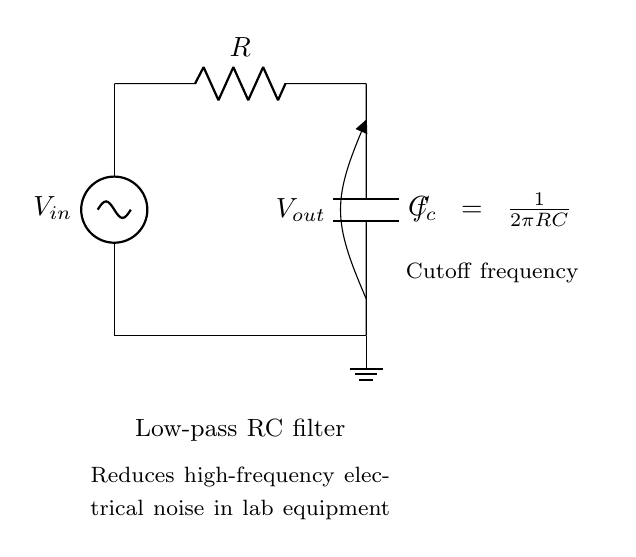What are the two main components in this circuit? The main components are a resistor and a capacitor, which are essential for the function of a low-pass RC filter.
Answer: Resistor and Capacitor What is the purpose of this low-pass filter? The purpose is to reduce high-frequency electrical noise in laboratory equipment, allowing only lower frequencies to pass through.
Answer: Reduce electrical noise What is labeled as the input voltage in this circuit? The input voltage is labeled as Vin, indicating where the voltage is applied to the circuit.
Answer: Vin What is the output voltage labeled in this circuit? The output voltage is labeled as Vout, which represents the voltage across the capacitor after filtering.
Answer: Vout What is the cutoff frequency formula indicated in the circuit? The cutoff frequency formula is expressed as fc = 1/(2πRC), which determines the frequency at which the output starts to drop in amplitude.
Answer: fc = 1/(2πRC) At high frequencies, what happens to the output voltage compared to the input voltage? At high frequencies, the output voltage decreases significantly compared to the input voltage due to the blocking effect of the capacitor, which impedes high-frequency signals.
Answer: Decreases significantly What effect does increasing the capacitance have on the cutoff frequency? Increasing the capacitance will lower the cutoff frequency, allowing even more low-frequency signals to pass while filtering out higher frequencies more effectively.
Answer: Lowers cutoff frequency 